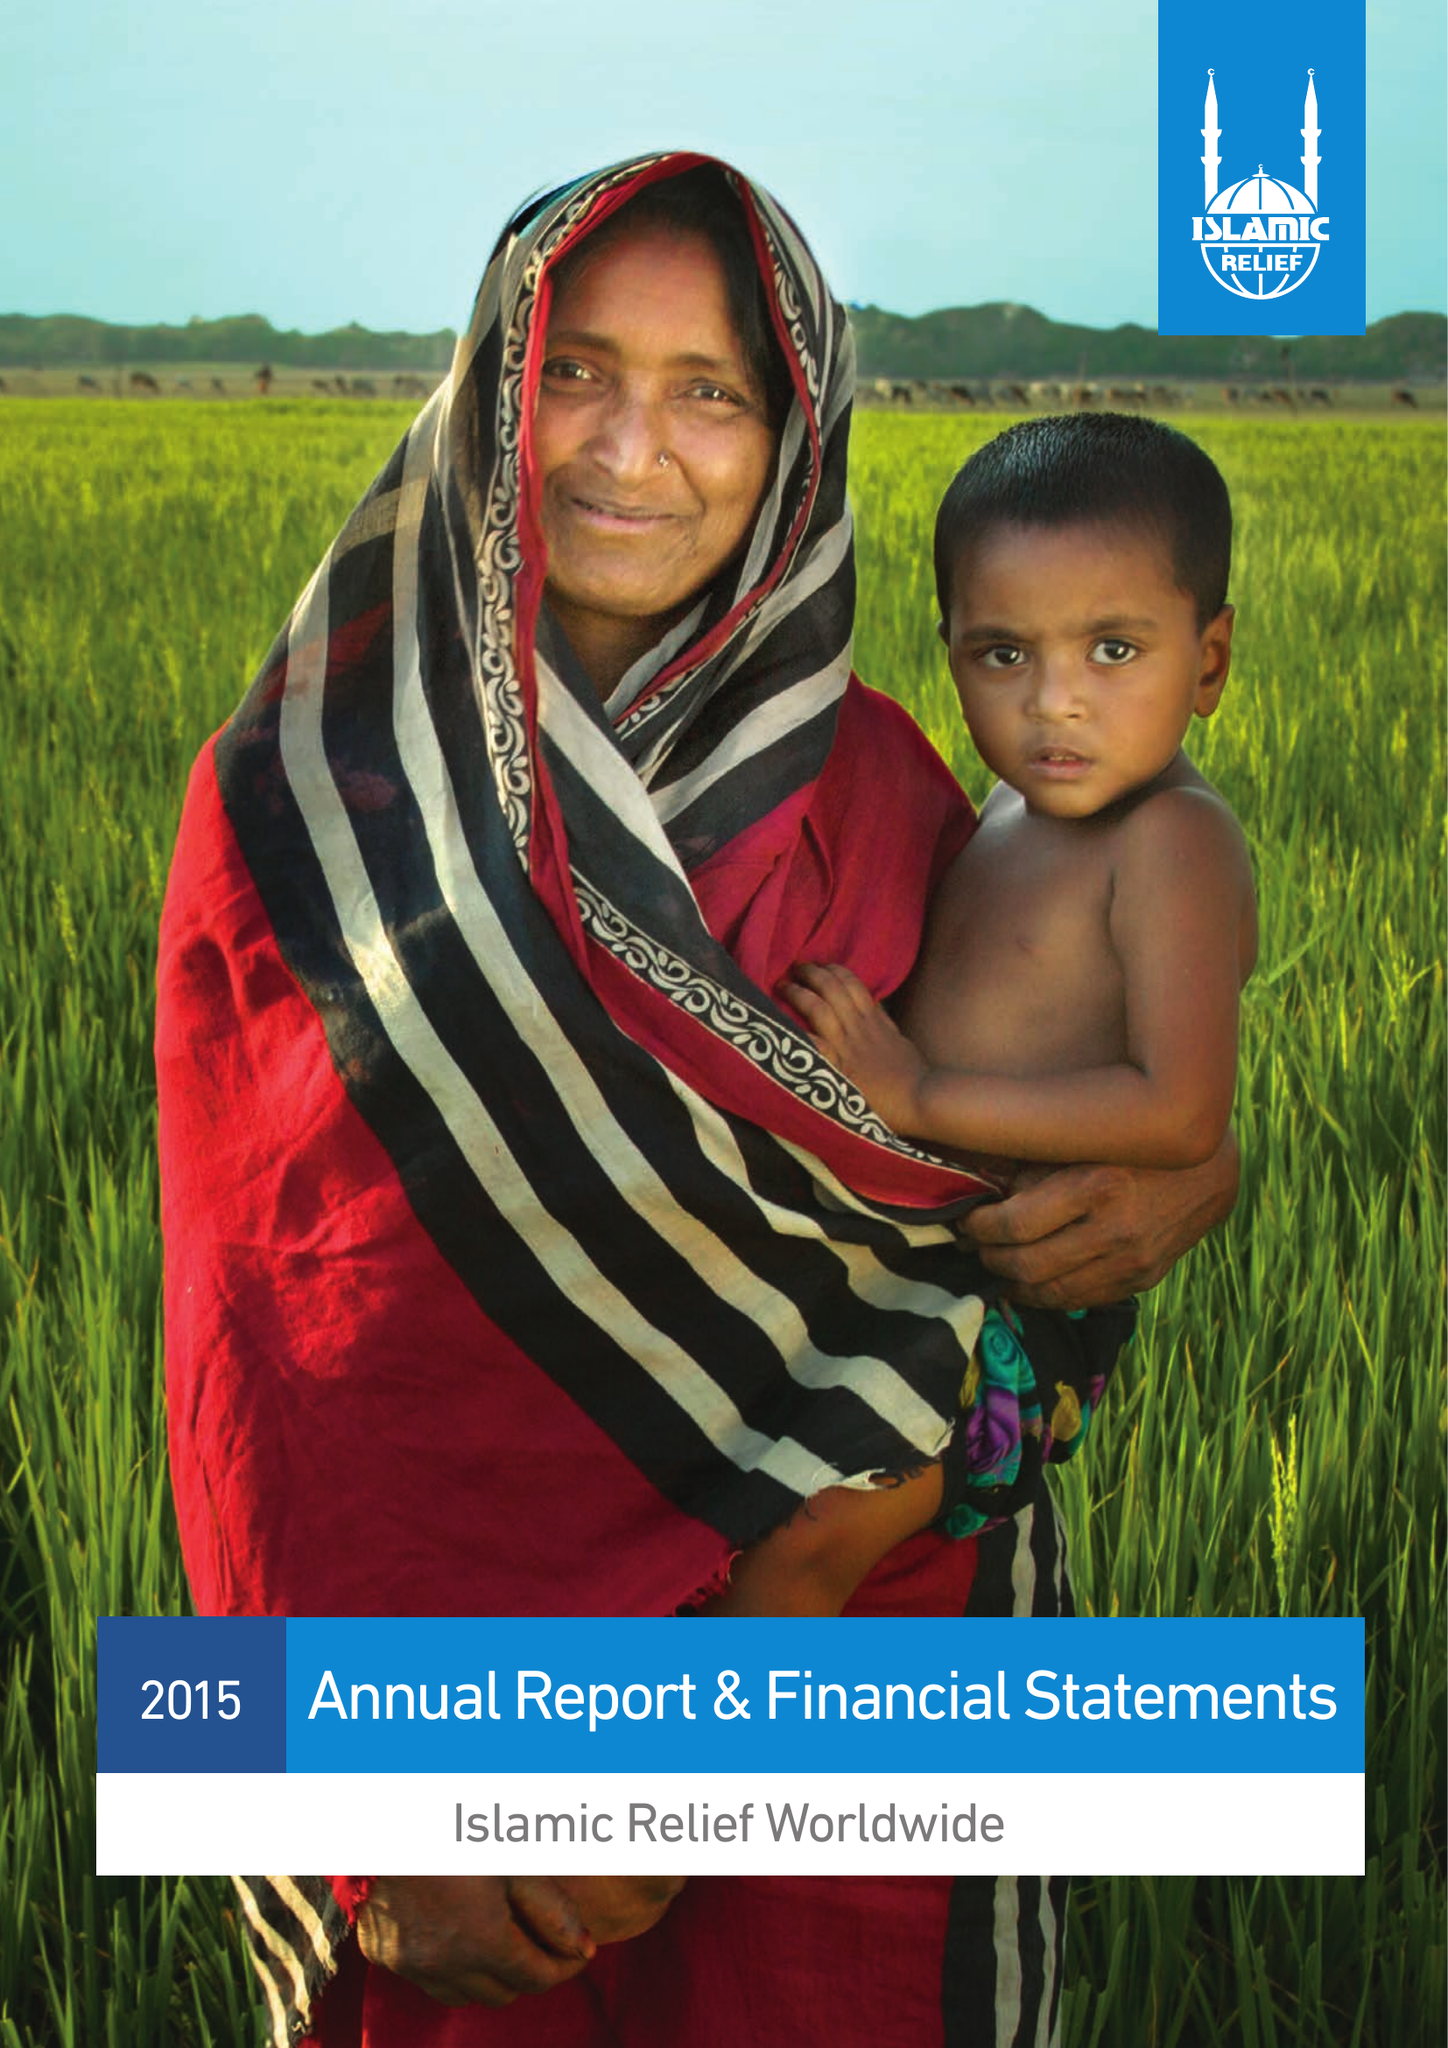What is the value for the address__postcode?
Answer the question using a single word or phrase. B5 6LB 